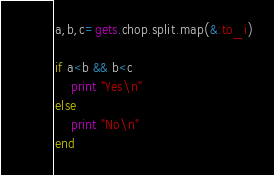<code> <loc_0><loc_0><loc_500><loc_500><_Ruby_>a,b,c=gets.chop.split.map(&:to_i)

if a<b && b<c
    print "Yes\n"
else
    print "No\n"
end

</code> 